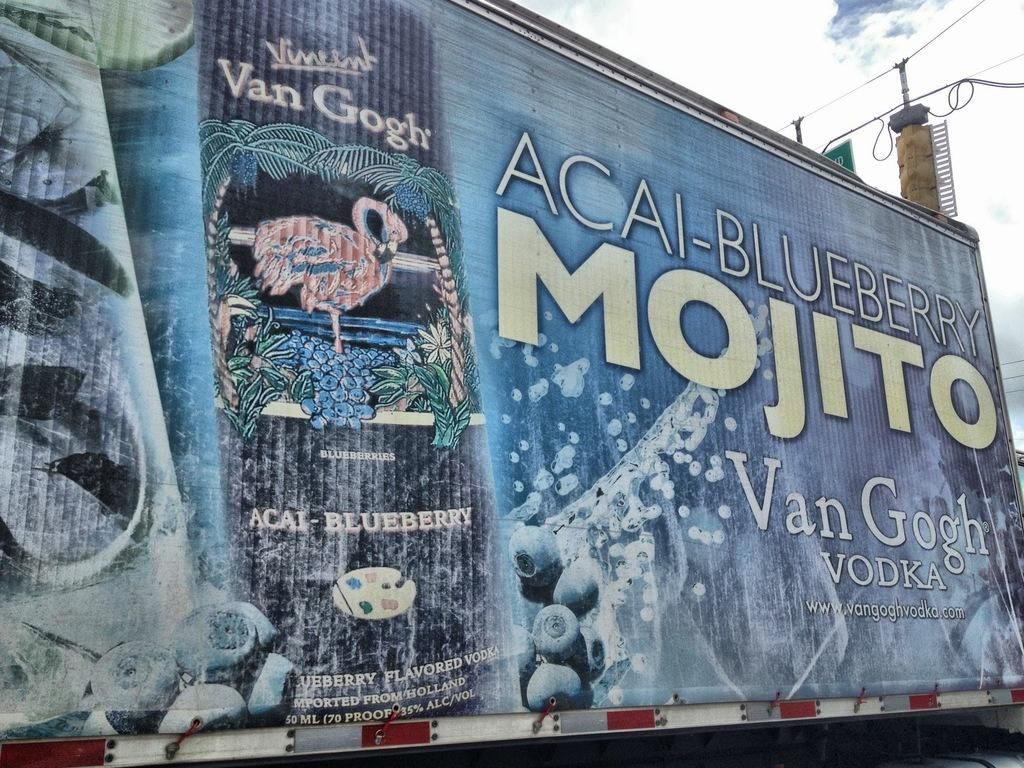<image>
Render a clear and concise summary of the photo. A large billboard that is painted with a can of acai blueberry mojito on it. 